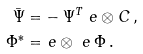<formula> <loc_0><loc_0><loc_500><loc_500>\bar { \Psi } = & - \Psi ^ { T } \ e \otimes C \, , \\ \Phi ^ { * } = & \ e \otimes \ e \, \Phi \, .</formula> 